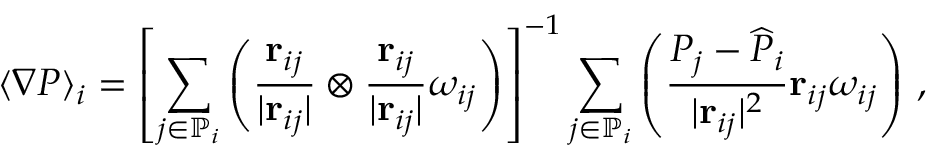Convert formula to latex. <formula><loc_0><loc_0><loc_500><loc_500>\langle \nabla P \rangle _ { i } = \left [ \sum _ { j \in \mathbb { P } _ { i } } \left ( \frac { r _ { i j } } { | r _ { i j } | } \otimes \frac { r _ { i j } } { | r _ { i j } | } \omega _ { i j } \right ) \right ] ^ { - 1 } \sum _ { j \in \mathbb { P } _ { i } } \left ( \frac { P _ { j } - \widehat { P } _ { i } } { | r _ { i j } | ^ { 2 } } r _ { i j } \omega _ { i j } \right ) \, ,</formula> 